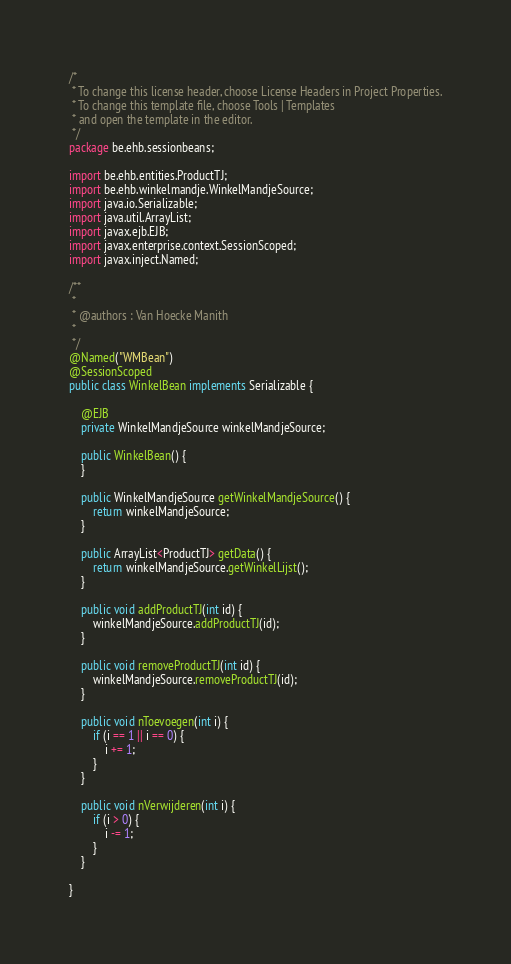<code> <loc_0><loc_0><loc_500><loc_500><_Java_>/*
 * To change this license header, choose License Headers in Project Properties.
 * To change this template file, choose Tools | Templates
 * and open the template in the editor.
 */
package be.ehb.sessionbeans;

import be.ehb.entities.ProductTJ;
import be.ehb.winkelmandje.WinkelMandjeSource;
import java.io.Serializable;
import java.util.ArrayList;
import javax.ejb.EJB;
import javax.enterprise.context.SessionScoped;
import javax.inject.Named;

/**
 *
 * @authors : Van Hoecke Manith
 *
 */
@Named("WMBean")
@SessionScoped
public class WinkelBean implements Serializable {

    @EJB
    private WinkelMandjeSource winkelMandjeSource;

    public WinkelBean() {
    }

    public WinkelMandjeSource getWinkelMandjeSource() {
        return winkelMandjeSource;
    }

    public ArrayList<ProductTJ> getData() {
        return winkelMandjeSource.getWinkelLijst();
    }

    public void addProductTJ(int id) {
        winkelMandjeSource.addProductTJ(id);
    }

    public void removeProductTJ(int id) {
        winkelMandjeSource.removeProductTJ(id);
    }

    public void nToevoegen(int i) {
        if (i == 1 || i == 0) {
            i += 1;
        }
    }

    public void nVerwijderen(int i) {
        if (i > 0) {
            i -= 1;
        }
    }

}
</code> 